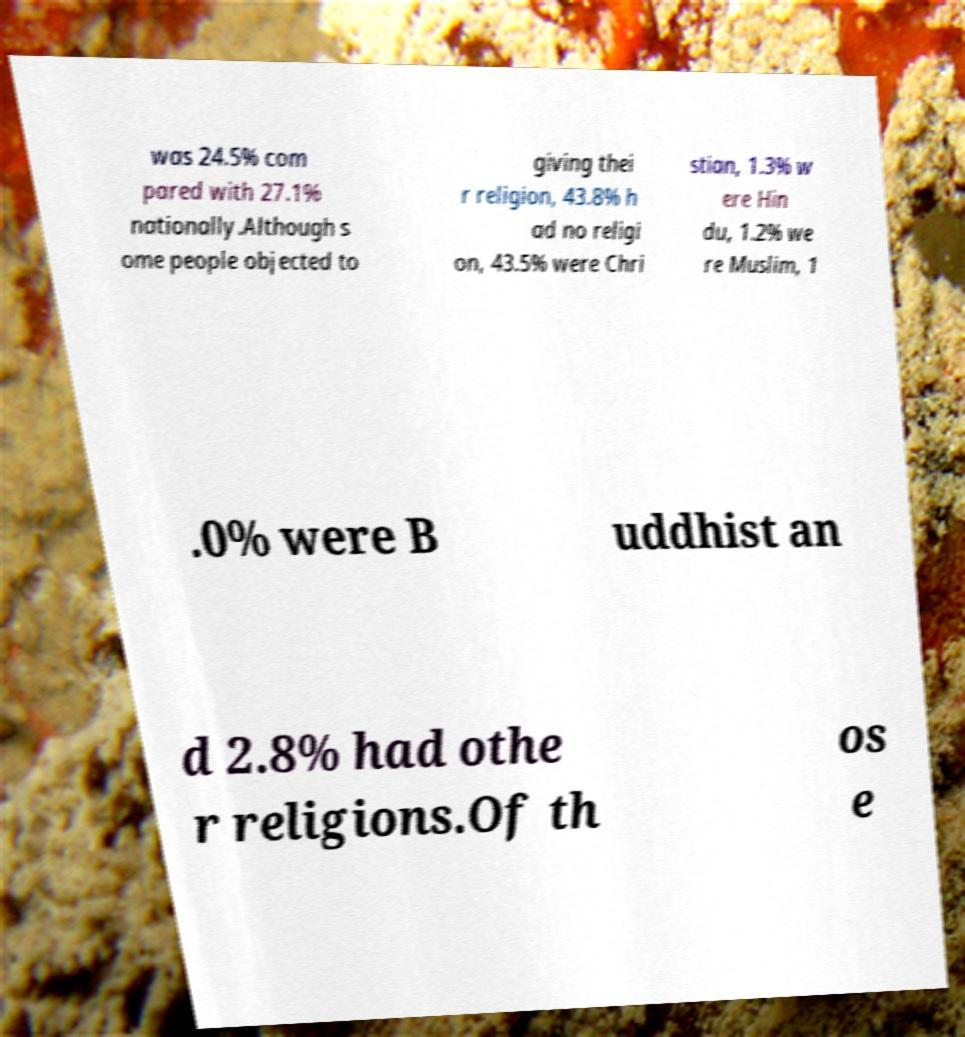There's text embedded in this image that I need extracted. Can you transcribe it verbatim? was 24.5% com pared with 27.1% nationally.Although s ome people objected to giving thei r religion, 43.8% h ad no religi on, 43.5% were Chri stian, 1.3% w ere Hin du, 1.2% we re Muslim, 1 .0% were B uddhist an d 2.8% had othe r religions.Of th os e 